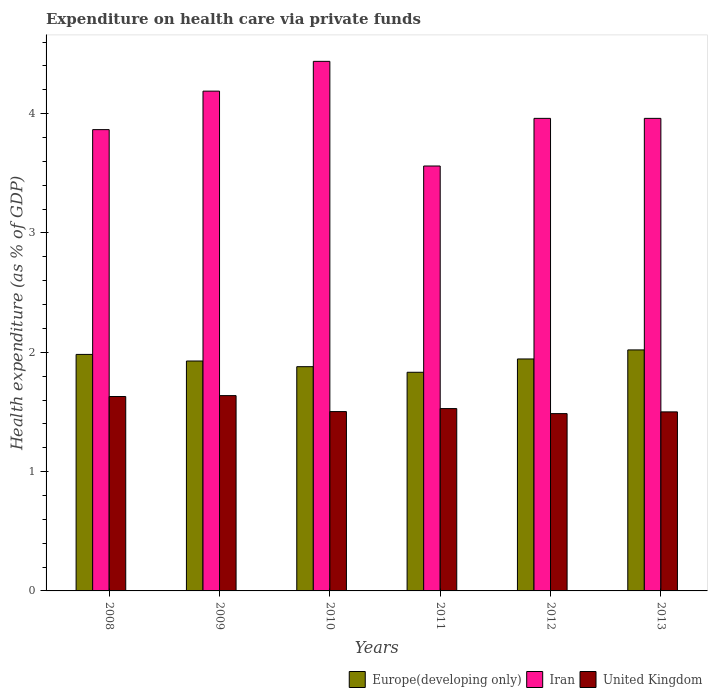How many different coloured bars are there?
Provide a short and direct response. 3. How many groups of bars are there?
Keep it short and to the point. 6. Are the number of bars per tick equal to the number of legend labels?
Offer a terse response. Yes. How many bars are there on the 3rd tick from the right?
Offer a terse response. 3. What is the expenditure made on health care in United Kingdom in 2008?
Provide a succinct answer. 1.63. Across all years, what is the maximum expenditure made on health care in Iran?
Provide a succinct answer. 4.44. Across all years, what is the minimum expenditure made on health care in United Kingdom?
Offer a very short reply. 1.49. In which year was the expenditure made on health care in United Kingdom maximum?
Give a very brief answer. 2009. In which year was the expenditure made on health care in Europe(developing only) minimum?
Keep it short and to the point. 2011. What is the total expenditure made on health care in Europe(developing only) in the graph?
Your response must be concise. 11.58. What is the difference between the expenditure made on health care in Iran in 2008 and that in 2010?
Your answer should be very brief. -0.57. What is the difference between the expenditure made on health care in Iran in 2012 and the expenditure made on health care in United Kingdom in 2013?
Ensure brevity in your answer.  2.46. What is the average expenditure made on health care in Europe(developing only) per year?
Keep it short and to the point. 1.93. In the year 2008, what is the difference between the expenditure made on health care in United Kingdom and expenditure made on health care in Iran?
Keep it short and to the point. -2.24. In how many years, is the expenditure made on health care in Iran greater than 3.4 %?
Make the answer very short. 6. What is the ratio of the expenditure made on health care in Europe(developing only) in 2009 to that in 2011?
Your answer should be compact. 1.05. Is the difference between the expenditure made on health care in United Kingdom in 2008 and 2011 greater than the difference between the expenditure made on health care in Iran in 2008 and 2011?
Your answer should be compact. No. What is the difference between the highest and the second highest expenditure made on health care in United Kingdom?
Ensure brevity in your answer.  0.01. What is the difference between the highest and the lowest expenditure made on health care in Iran?
Make the answer very short. 0.88. What does the 2nd bar from the left in 2008 represents?
Your response must be concise. Iran. What does the 2nd bar from the right in 2009 represents?
Offer a terse response. Iran. How many bars are there?
Ensure brevity in your answer.  18. Are all the bars in the graph horizontal?
Provide a succinct answer. No. What is the difference between two consecutive major ticks on the Y-axis?
Provide a succinct answer. 1. Does the graph contain any zero values?
Your response must be concise. No. Does the graph contain grids?
Give a very brief answer. No. Where does the legend appear in the graph?
Make the answer very short. Bottom right. How many legend labels are there?
Provide a short and direct response. 3. How are the legend labels stacked?
Your answer should be very brief. Horizontal. What is the title of the graph?
Ensure brevity in your answer.  Expenditure on health care via private funds. What is the label or title of the X-axis?
Ensure brevity in your answer.  Years. What is the label or title of the Y-axis?
Offer a terse response. Health expenditure (as % of GDP). What is the Health expenditure (as % of GDP) in Europe(developing only) in 2008?
Your answer should be very brief. 1.98. What is the Health expenditure (as % of GDP) of Iran in 2008?
Offer a terse response. 3.87. What is the Health expenditure (as % of GDP) in United Kingdom in 2008?
Give a very brief answer. 1.63. What is the Health expenditure (as % of GDP) in Europe(developing only) in 2009?
Keep it short and to the point. 1.93. What is the Health expenditure (as % of GDP) in Iran in 2009?
Ensure brevity in your answer.  4.19. What is the Health expenditure (as % of GDP) of United Kingdom in 2009?
Provide a succinct answer. 1.64. What is the Health expenditure (as % of GDP) of Europe(developing only) in 2010?
Your answer should be very brief. 1.88. What is the Health expenditure (as % of GDP) in Iran in 2010?
Offer a terse response. 4.44. What is the Health expenditure (as % of GDP) of United Kingdom in 2010?
Your answer should be very brief. 1.5. What is the Health expenditure (as % of GDP) of Europe(developing only) in 2011?
Offer a very short reply. 1.83. What is the Health expenditure (as % of GDP) in Iran in 2011?
Make the answer very short. 3.56. What is the Health expenditure (as % of GDP) in United Kingdom in 2011?
Your answer should be compact. 1.53. What is the Health expenditure (as % of GDP) in Europe(developing only) in 2012?
Keep it short and to the point. 1.94. What is the Health expenditure (as % of GDP) of Iran in 2012?
Make the answer very short. 3.96. What is the Health expenditure (as % of GDP) in United Kingdom in 2012?
Your response must be concise. 1.49. What is the Health expenditure (as % of GDP) of Europe(developing only) in 2013?
Ensure brevity in your answer.  2.02. What is the Health expenditure (as % of GDP) in Iran in 2013?
Provide a short and direct response. 3.96. What is the Health expenditure (as % of GDP) of United Kingdom in 2013?
Your answer should be compact. 1.5. Across all years, what is the maximum Health expenditure (as % of GDP) of Europe(developing only)?
Offer a very short reply. 2.02. Across all years, what is the maximum Health expenditure (as % of GDP) of Iran?
Offer a terse response. 4.44. Across all years, what is the maximum Health expenditure (as % of GDP) in United Kingdom?
Give a very brief answer. 1.64. Across all years, what is the minimum Health expenditure (as % of GDP) of Europe(developing only)?
Your response must be concise. 1.83. Across all years, what is the minimum Health expenditure (as % of GDP) of Iran?
Make the answer very short. 3.56. Across all years, what is the minimum Health expenditure (as % of GDP) in United Kingdom?
Provide a succinct answer. 1.49. What is the total Health expenditure (as % of GDP) in Europe(developing only) in the graph?
Your answer should be very brief. 11.58. What is the total Health expenditure (as % of GDP) in Iran in the graph?
Your answer should be very brief. 23.97. What is the total Health expenditure (as % of GDP) in United Kingdom in the graph?
Keep it short and to the point. 9.28. What is the difference between the Health expenditure (as % of GDP) of Europe(developing only) in 2008 and that in 2009?
Ensure brevity in your answer.  0.06. What is the difference between the Health expenditure (as % of GDP) in Iran in 2008 and that in 2009?
Your answer should be compact. -0.32. What is the difference between the Health expenditure (as % of GDP) in United Kingdom in 2008 and that in 2009?
Offer a very short reply. -0.01. What is the difference between the Health expenditure (as % of GDP) of Europe(developing only) in 2008 and that in 2010?
Offer a terse response. 0.1. What is the difference between the Health expenditure (as % of GDP) in Iran in 2008 and that in 2010?
Your answer should be very brief. -0.57. What is the difference between the Health expenditure (as % of GDP) of United Kingdom in 2008 and that in 2010?
Your answer should be compact. 0.13. What is the difference between the Health expenditure (as % of GDP) of Europe(developing only) in 2008 and that in 2011?
Offer a terse response. 0.15. What is the difference between the Health expenditure (as % of GDP) of Iran in 2008 and that in 2011?
Ensure brevity in your answer.  0.3. What is the difference between the Health expenditure (as % of GDP) of United Kingdom in 2008 and that in 2011?
Make the answer very short. 0.1. What is the difference between the Health expenditure (as % of GDP) of Europe(developing only) in 2008 and that in 2012?
Ensure brevity in your answer.  0.04. What is the difference between the Health expenditure (as % of GDP) of Iran in 2008 and that in 2012?
Give a very brief answer. -0.09. What is the difference between the Health expenditure (as % of GDP) of United Kingdom in 2008 and that in 2012?
Ensure brevity in your answer.  0.14. What is the difference between the Health expenditure (as % of GDP) of Europe(developing only) in 2008 and that in 2013?
Offer a very short reply. -0.04. What is the difference between the Health expenditure (as % of GDP) in Iran in 2008 and that in 2013?
Ensure brevity in your answer.  -0.09. What is the difference between the Health expenditure (as % of GDP) of United Kingdom in 2008 and that in 2013?
Your answer should be compact. 0.13. What is the difference between the Health expenditure (as % of GDP) in Europe(developing only) in 2009 and that in 2010?
Provide a succinct answer. 0.05. What is the difference between the Health expenditure (as % of GDP) in Iran in 2009 and that in 2010?
Ensure brevity in your answer.  -0.25. What is the difference between the Health expenditure (as % of GDP) of United Kingdom in 2009 and that in 2010?
Your answer should be very brief. 0.13. What is the difference between the Health expenditure (as % of GDP) in Europe(developing only) in 2009 and that in 2011?
Your answer should be compact. 0.09. What is the difference between the Health expenditure (as % of GDP) of Iran in 2009 and that in 2011?
Offer a very short reply. 0.63. What is the difference between the Health expenditure (as % of GDP) of United Kingdom in 2009 and that in 2011?
Your answer should be compact. 0.11. What is the difference between the Health expenditure (as % of GDP) of Europe(developing only) in 2009 and that in 2012?
Ensure brevity in your answer.  -0.02. What is the difference between the Health expenditure (as % of GDP) in Iran in 2009 and that in 2012?
Offer a very short reply. 0.23. What is the difference between the Health expenditure (as % of GDP) in United Kingdom in 2009 and that in 2012?
Your response must be concise. 0.15. What is the difference between the Health expenditure (as % of GDP) of Europe(developing only) in 2009 and that in 2013?
Provide a short and direct response. -0.09. What is the difference between the Health expenditure (as % of GDP) in Iran in 2009 and that in 2013?
Provide a short and direct response. 0.23. What is the difference between the Health expenditure (as % of GDP) of United Kingdom in 2009 and that in 2013?
Provide a short and direct response. 0.14. What is the difference between the Health expenditure (as % of GDP) of Europe(developing only) in 2010 and that in 2011?
Your answer should be very brief. 0.05. What is the difference between the Health expenditure (as % of GDP) of Iran in 2010 and that in 2011?
Keep it short and to the point. 0.88. What is the difference between the Health expenditure (as % of GDP) in United Kingdom in 2010 and that in 2011?
Offer a very short reply. -0.03. What is the difference between the Health expenditure (as % of GDP) of Europe(developing only) in 2010 and that in 2012?
Make the answer very short. -0.06. What is the difference between the Health expenditure (as % of GDP) in Iran in 2010 and that in 2012?
Offer a terse response. 0.48. What is the difference between the Health expenditure (as % of GDP) in United Kingdom in 2010 and that in 2012?
Give a very brief answer. 0.02. What is the difference between the Health expenditure (as % of GDP) in Europe(developing only) in 2010 and that in 2013?
Your answer should be compact. -0.14. What is the difference between the Health expenditure (as % of GDP) of Iran in 2010 and that in 2013?
Ensure brevity in your answer.  0.48. What is the difference between the Health expenditure (as % of GDP) in United Kingdom in 2010 and that in 2013?
Ensure brevity in your answer.  0. What is the difference between the Health expenditure (as % of GDP) in Europe(developing only) in 2011 and that in 2012?
Ensure brevity in your answer.  -0.11. What is the difference between the Health expenditure (as % of GDP) in Iran in 2011 and that in 2012?
Your response must be concise. -0.4. What is the difference between the Health expenditure (as % of GDP) of United Kingdom in 2011 and that in 2012?
Offer a terse response. 0.04. What is the difference between the Health expenditure (as % of GDP) in Europe(developing only) in 2011 and that in 2013?
Give a very brief answer. -0.19. What is the difference between the Health expenditure (as % of GDP) of Iran in 2011 and that in 2013?
Make the answer very short. -0.4. What is the difference between the Health expenditure (as % of GDP) of United Kingdom in 2011 and that in 2013?
Offer a very short reply. 0.03. What is the difference between the Health expenditure (as % of GDP) in Europe(developing only) in 2012 and that in 2013?
Offer a very short reply. -0.08. What is the difference between the Health expenditure (as % of GDP) in Iran in 2012 and that in 2013?
Keep it short and to the point. 0. What is the difference between the Health expenditure (as % of GDP) in United Kingdom in 2012 and that in 2013?
Give a very brief answer. -0.01. What is the difference between the Health expenditure (as % of GDP) of Europe(developing only) in 2008 and the Health expenditure (as % of GDP) of Iran in 2009?
Your answer should be compact. -2.21. What is the difference between the Health expenditure (as % of GDP) of Europe(developing only) in 2008 and the Health expenditure (as % of GDP) of United Kingdom in 2009?
Offer a terse response. 0.35. What is the difference between the Health expenditure (as % of GDP) in Iran in 2008 and the Health expenditure (as % of GDP) in United Kingdom in 2009?
Ensure brevity in your answer.  2.23. What is the difference between the Health expenditure (as % of GDP) of Europe(developing only) in 2008 and the Health expenditure (as % of GDP) of Iran in 2010?
Provide a succinct answer. -2.46. What is the difference between the Health expenditure (as % of GDP) of Europe(developing only) in 2008 and the Health expenditure (as % of GDP) of United Kingdom in 2010?
Give a very brief answer. 0.48. What is the difference between the Health expenditure (as % of GDP) of Iran in 2008 and the Health expenditure (as % of GDP) of United Kingdom in 2010?
Your response must be concise. 2.36. What is the difference between the Health expenditure (as % of GDP) of Europe(developing only) in 2008 and the Health expenditure (as % of GDP) of Iran in 2011?
Your response must be concise. -1.58. What is the difference between the Health expenditure (as % of GDP) of Europe(developing only) in 2008 and the Health expenditure (as % of GDP) of United Kingdom in 2011?
Your answer should be very brief. 0.45. What is the difference between the Health expenditure (as % of GDP) in Iran in 2008 and the Health expenditure (as % of GDP) in United Kingdom in 2011?
Keep it short and to the point. 2.34. What is the difference between the Health expenditure (as % of GDP) in Europe(developing only) in 2008 and the Health expenditure (as % of GDP) in Iran in 2012?
Your response must be concise. -1.98. What is the difference between the Health expenditure (as % of GDP) in Europe(developing only) in 2008 and the Health expenditure (as % of GDP) in United Kingdom in 2012?
Your answer should be very brief. 0.5. What is the difference between the Health expenditure (as % of GDP) in Iran in 2008 and the Health expenditure (as % of GDP) in United Kingdom in 2012?
Offer a very short reply. 2.38. What is the difference between the Health expenditure (as % of GDP) in Europe(developing only) in 2008 and the Health expenditure (as % of GDP) in Iran in 2013?
Make the answer very short. -1.98. What is the difference between the Health expenditure (as % of GDP) of Europe(developing only) in 2008 and the Health expenditure (as % of GDP) of United Kingdom in 2013?
Your answer should be compact. 0.48. What is the difference between the Health expenditure (as % of GDP) of Iran in 2008 and the Health expenditure (as % of GDP) of United Kingdom in 2013?
Your answer should be compact. 2.37. What is the difference between the Health expenditure (as % of GDP) in Europe(developing only) in 2009 and the Health expenditure (as % of GDP) in Iran in 2010?
Make the answer very short. -2.51. What is the difference between the Health expenditure (as % of GDP) of Europe(developing only) in 2009 and the Health expenditure (as % of GDP) of United Kingdom in 2010?
Offer a very short reply. 0.42. What is the difference between the Health expenditure (as % of GDP) of Iran in 2009 and the Health expenditure (as % of GDP) of United Kingdom in 2010?
Provide a short and direct response. 2.69. What is the difference between the Health expenditure (as % of GDP) in Europe(developing only) in 2009 and the Health expenditure (as % of GDP) in Iran in 2011?
Your answer should be compact. -1.63. What is the difference between the Health expenditure (as % of GDP) of Europe(developing only) in 2009 and the Health expenditure (as % of GDP) of United Kingdom in 2011?
Keep it short and to the point. 0.4. What is the difference between the Health expenditure (as % of GDP) in Iran in 2009 and the Health expenditure (as % of GDP) in United Kingdom in 2011?
Make the answer very short. 2.66. What is the difference between the Health expenditure (as % of GDP) of Europe(developing only) in 2009 and the Health expenditure (as % of GDP) of Iran in 2012?
Offer a terse response. -2.03. What is the difference between the Health expenditure (as % of GDP) of Europe(developing only) in 2009 and the Health expenditure (as % of GDP) of United Kingdom in 2012?
Give a very brief answer. 0.44. What is the difference between the Health expenditure (as % of GDP) of Iran in 2009 and the Health expenditure (as % of GDP) of United Kingdom in 2012?
Offer a terse response. 2.7. What is the difference between the Health expenditure (as % of GDP) in Europe(developing only) in 2009 and the Health expenditure (as % of GDP) in Iran in 2013?
Provide a succinct answer. -2.03. What is the difference between the Health expenditure (as % of GDP) in Europe(developing only) in 2009 and the Health expenditure (as % of GDP) in United Kingdom in 2013?
Provide a succinct answer. 0.43. What is the difference between the Health expenditure (as % of GDP) in Iran in 2009 and the Health expenditure (as % of GDP) in United Kingdom in 2013?
Your answer should be very brief. 2.69. What is the difference between the Health expenditure (as % of GDP) in Europe(developing only) in 2010 and the Health expenditure (as % of GDP) in Iran in 2011?
Offer a very short reply. -1.68. What is the difference between the Health expenditure (as % of GDP) of Europe(developing only) in 2010 and the Health expenditure (as % of GDP) of United Kingdom in 2011?
Provide a short and direct response. 0.35. What is the difference between the Health expenditure (as % of GDP) of Iran in 2010 and the Health expenditure (as % of GDP) of United Kingdom in 2011?
Your answer should be compact. 2.91. What is the difference between the Health expenditure (as % of GDP) of Europe(developing only) in 2010 and the Health expenditure (as % of GDP) of Iran in 2012?
Ensure brevity in your answer.  -2.08. What is the difference between the Health expenditure (as % of GDP) of Europe(developing only) in 2010 and the Health expenditure (as % of GDP) of United Kingdom in 2012?
Keep it short and to the point. 0.39. What is the difference between the Health expenditure (as % of GDP) in Iran in 2010 and the Health expenditure (as % of GDP) in United Kingdom in 2012?
Your answer should be compact. 2.95. What is the difference between the Health expenditure (as % of GDP) of Europe(developing only) in 2010 and the Health expenditure (as % of GDP) of Iran in 2013?
Your answer should be very brief. -2.08. What is the difference between the Health expenditure (as % of GDP) in Europe(developing only) in 2010 and the Health expenditure (as % of GDP) in United Kingdom in 2013?
Ensure brevity in your answer.  0.38. What is the difference between the Health expenditure (as % of GDP) of Iran in 2010 and the Health expenditure (as % of GDP) of United Kingdom in 2013?
Your answer should be very brief. 2.94. What is the difference between the Health expenditure (as % of GDP) of Europe(developing only) in 2011 and the Health expenditure (as % of GDP) of Iran in 2012?
Provide a short and direct response. -2.13. What is the difference between the Health expenditure (as % of GDP) in Europe(developing only) in 2011 and the Health expenditure (as % of GDP) in United Kingdom in 2012?
Keep it short and to the point. 0.35. What is the difference between the Health expenditure (as % of GDP) in Iran in 2011 and the Health expenditure (as % of GDP) in United Kingdom in 2012?
Your answer should be very brief. 2.08. What is the difference between the Health expenditure (as % of GDP) of Europe(developing only) in 2011 and the Health expenditure (as % of GDP) of Iran in 2013?
Ensure brevity in your answer.  -2.13. What is the difference between the Health expenditure (as % of GDP) of Europe(developing only) in 2011 and the Health expenditure (as % of GDP) of United Kingdom in 2013?
Offer a very short reply. 0.33. What is the difference between the Health expenditure (as % of GDP) in Iran in 2011 and the Health expenditure (as % of GDP) in United Kingdom in 2013?
Ensure brevity in your answer.  2.06. What is the difference between the Health expenditure (as % of GDP) of Europe(developing only) in 2012 and the Health expenditure (as % of GDP) of Iran in 2013?
Give a very brief answer. -2.02. What is the difference between the Health expenditure (as % of GDP) of Europe(developing only) in 2012 and the Health expenditure (as % of GDP) of United Kingdom in 2013?
Offer a terse response. 0.44. What is the difference between the Health expenditure (as % of GDP) of Iran in 2012 and the Health expenditure (as % of GDP) of United Kingdom in 2013?
Your answer should be compact. 2.46. What is the average Health expenditure (as % of GDP) of Europe(developing only) per year?
Provide a short and direct response. 1.93. What is the average Health expenditure (as % of GDP) of Iran per year?
Your answer should be very brief. 4. What is the average Health expenditure (as % of GDP) of United Kingdom per year?
Offer a very short reply. 1.55. In the year 2008, what is the difference between the Health expenditure (as % of GDP) of Europe(developing only) and Health expenditure (as % of GDP) of Iran?
Make the answer very short. -1.88. In the year 2008, what is the difference between the Health expenditure (as % of GDP) of Europe(developing only) and Health expenditure (as % of GDP) of United Kingdom?
Offer a very short reply. 0.35. In the year 2008, what is the difference between the Health expenditure (as % of GDP) of Iran and Health expenditure (as % of GDP) of United Kingdom?
Provide a short and direct response. 2.24. In the year 2009, what is the difference between the Health expenditure (as % of GDP) in Europe(developing only) and Health expenditure (as % of GDP) in Iran?
Ensure brevity in your answer.  -2.26. In the year 2009, what is the difference between the Health expenditure (as % of GDP) in Europe(developing only) and Health expenditure (as % of GDP) in United Kingdom?
Your answer should be compact. 0.29. In the year 2009, what is the difference between the Health expenditure (as % of GDP) of Iran and Health expenditure (as % of GDP) of United Kingdom?
Provide a short and direct response. 2.55. In the year 2010, what is the difference between the Health expenditure (as % of GDP) in Europe(developing only) and Health expenditure (as % of GDP) in Iran?
Give a very brief answer. -2.56. In the year 2010, what is the difference between the Health expenditure (as % of GDP) of Europe(developing only) and Health expenditure (as % of GDP) of United Kingdom?
Keep it short and to the point. 0.38. In the year 2010, what is the difference between the Health expenditure (as % of GDP) of Iran and Health expenditure (as % of GDP) of United Kingdom?
Your answer should be very brief. 2.94. In the year 2011, what is the difference between the Health expenditure (as % of GDP) in Europe(developing only) and Health expenditure (as % of GDP) in Iran?
Your response must be concise. -1.73. In the year 2011, what is the difference between the Health expenditure (as % of GDP) of Europe(developing only) and Health expenditure (as % of GDP) of United Kingdom?
Make the answer very short. 0.3. In the year 2011, what is the difference between the Health expenditure (as % of GDP) of Iran and Health expenditure (as % of GDP) of United Kingdom?
Give a very brief answer. 2.03. In the year 2012, what is the difference between the Health expenditure (as % of GDP) in Europe(developing only) and Health expenditure (as % of GDP) in Iran?
Provide a short and direct response. -2.02. In the year 2012, what is the difference between the Health expenditure (as % of GDP) in Europe(developing only) and Health expenditure (as % of GDP) in United Kingdom?
Ensure brevity in your answer.  0.46. In the year 2012, what is the difference between the Health expenditure (as % of GDP) in Iran and Health expenditure (as % of GDP) in United Kingdom?
Your response must be concise. 2.47. In the year 2013, what is the difference between the Health expenditure (as % of GDP) in Europe(developing only) and Health expenditure (as % of GDP) in Iran?
Ensure brevity in your answer.  -1.94. In the year 2013, what is the difference between the Health expenditure (as % of GDP) of Europe(developing only) and Health expenditure (as % of GDP) of United Kingdom?
Your answer should be compact. 0.52. In the year 2013, what is the difference between the Health expenditure (as % of GDP) in Iran and Health expenditure (as % of GDP) in United Kingdom?
Your response must be concise. 2.46. What is the ratio of the Health expenditure (as % of GDP) in Europe(developing only) in 2008 to that in 2009?
Your answer should be compact. 1.03. What is the ratio of the Health expenditure (as % of GDP) of Iran in 2008 to that in 2009?
Offer a very short reply. 0.92. What is the ratio of the Health expenditure (as % of GDP) of United Kingdom in 2008 to that in 2009?
Offer a terse response. 1. What is the ratio of the Health expenditure (as % of GDP) in Europe(developing only) in 2008 to that in 2010?
Keep it short and to the point. 1.05. What is the ratio of the Health expenditure (as % of GDP) in Iran in 2008 to that in 2010?
Provide a short and direct response. 0.87. What is the ratio of the Health expenditure (as % of GDP) in United Kingdom in 2008 to that in 2010?
Your response must be concise. 1.08. What is the ratio of the Health expenditure (as % of GDP) in Europe(developing only) in 2008 to that in 2011?
Your response must be concise. 1.08. What is the ratio of the Health expenditure (as % of GDP) of Iran in 2008 to that in 2011?
Your answer should be compact. 1.09. What is the ratio of the Health expenditure (as % of GDP) of United Kingdom in 2008 to that in 2011?
Offer a very short reply. 1.07. What is the ratio of the Health expenditure (as % of GDP) in Europe(developing only) in 2008 to that in 2012?
Provide a succinct answer. 1.02. What is the ratio of the Health expenditure (as % of GDP) in Iran in 2008 to that in 2012?
Your response must be concise. 0.98. What is the ratio of the Health expenditure (as % of GDP) in United Kingdom in 2008 to that in 2012?
Your answer should be compact. 1.1. What is the ratio of the Health expenditure (as % of GDP) in Europe(developing only) in 2008 to that in 2013?
Make the answer very short. 0.98. What is the ratio of the Health expenditure (as % of GDP) of Iran in 2008 to that in 2013?
Give a very brief answer. 0.98. What is the ratio of the Health expenditure (as % of GDP) of United Kingdom in 2008 to that in 2013?
Your response must be concise. 1.09. What is the ratio of the Health expenditure (as % of GDP) in Europe(developing only) in 2009 to that in 2010?
Keep it short and to the point. 1.03. What is the ratio of the Health expenditure (as % of GDP) in Iran in 2009 to that in 2010?
Make the answer very short. 0.94. What is the ratio of the Health expenditure (as % of GDP) of United Kingdom in 2009 to that in 2010?
Offer a very short reply. 1.09. What is the ratio of the Health expenditure (as % of GDP) in Europe(developing only) in 2009 to that in 2011?
Offer a terse response. 1.05. What is the ratio of the Health expenditure (as % of GDP) of Iran in 2009 to that in 2011?
Ensure brevity in your answer.  1.18. What is the ratio of the Health expenditure (as % of GDP) in United Kingdom in 2009 to that in 2011?
Keep it short and to the point. 1.07. What is the ratio of the Health expenditure (as % of GDP) in Iran in 2009 to that in 2012?
Your answer should be very brief. 1.06. What is the ratio of the Health expenditure (as % of GDP) of United Kingdom in 2009 to that in 2012?
Your response must be concise. 1.1. What is the ratio of the Health expenditure (as % of GDP) of Europe(developing only) in 2009 to that in 2013?
Make the answer very short. 0.95. What is the ratio of the Health expenditure (as % of GDP) of Iran in 2009 to that in 2013?
Keep it short and to the point. 1.06. What is the ratio of the Health expenditure (as % of GDP) of United Kingdom in 2009 to that in 2013?
Give a very brief answer. 1.09. What is the ratio of the Health expenditure (as % of GDP) in Europe(developing only) in 2010 to that in 2011?
Offer a terse response. 1.03. What is the ratio of the Health expenditure (as % of GDP) in Iran in 2010 to that in 2011?
Provide a short and direct response. 1.25. What is the ratio of the Health expenditure (as % of GDP) of United Kingdom in 2010 to that in 2011?
Your answer should be very brief. 0.98. What is the ratio of the Health expenditure (as % of GDP) in Europe(developing only) in 2010 to that in 2012?
Offer a terse response. 0.97. What is the ratio of the Health expenditure (as % of GDP) of Iran in 2010 to that in 2012?
Offer a terse response. 1.12. What is the ratio of the Health expenditure (as % of GDP) in United Kingdom in 2010 to that in 2012?
Keep it short and to the point. 1.01. What is the ratio of the Health expenditure (as % of GDP) of Europe(developing only) in 2010 to that in 2013?
Offer a terse response. 0.93. What is the ratio of the Health expenditure (as % of GDP) of Iran in 2010 to that in 2013?
Keep it short and to the point. 1.12. What is the ratio of the Health expenditure (as % of GDP) in United Kingdom in 2010 to that in 2013?
Ensure brevity in your answer.  1. What is the ratio of the Health expenditure (as % of GDP) of Europe(developing only) in 2011 to that in 2012?
Your response must be concise. 0.94. What is the ratio of the Health expenditure (as % of GDP) of Iran in 2011 to that in 2012?
Offer a terse response. 0.9. What is the ratio of the Health expenditure (as % of GDP) of United Kingdom in 2011 to that in 2012?
Ensure brevity in your answer.  1.03. What is the ratio of the Health expenditure (as % of GDP) in Europe(developing only) in 2011 to that in 2013?
Provide a succinct answer. 0.91. What is the ratio of the Health expenditure (as % of GDP) in Iran in 2011 to that in 2013?
Make the answer very short. 0.9. What is the ratio of the Health expenditure (as % of GDP) in United Kingdom in 2011 to that in 2013?
Offer a terse response. 1.02. What is the ratio of the Health expenditure (as % of GDP) of Europe(developing only) in 2012 to that in 2013?
Provide a short and direct response. 0.96. What is the ratio of the Health expenditure (as % of GDP) in Iran in 2012 to that in 2013?
Give a very brief answer. 1. What is the difference between the highest and the second highest Health expenditure (as % of GDP) of Europe(developing only)?
Keep it short and to the point. 0.04. What is the difference between the highest and the second highest Health expenditure (as % of GDP) of Iran?
Your answer should be very brief. 0.25. What is the difference between the highest and the second highest Health expenditure (as % of GDP) in United Kingdom?
Offer a terse response. 0.01. What is the difference between the highest and the lowest Health expenditure (as % of GDP) in Europe(developing only)?
Your answer should be compact. 0.19. What is the difference between the highest and the lowest Health expenditure (as % of GDP) in Iran?
Make the answer very short. 0.88. What is the difference between the highest and the lowest Health expenditure (as % of GDP) in United Kingdom?
Ensure brevity in your answer.  0.15. 